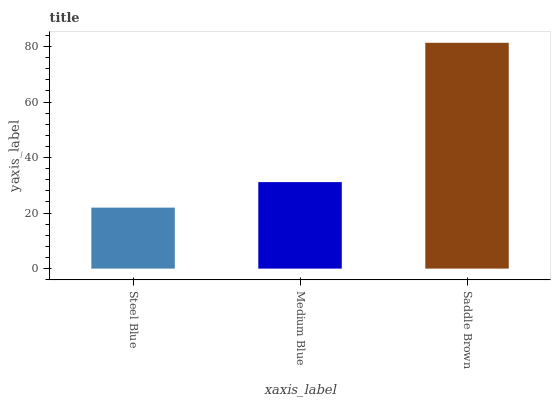Is Medium Blue the minimum?
Answer yes or no. No. Is Medium Blue the maximum?
Answer yes or no. No. Is Medium Blue greater than Steel Blue?
Answer yes or no. Yes. Is Steel Blue less than Medium Blue?
Answer yes or no. Yes. Is Steel Blue greater than Medium Blue?
Answer yes or no. No. Is Medium Blue less than Steel Blue?
Answer yes or no. No. Is Medium Blue the high median?
Answer yes or no. Yes. Is Medium Blue the low median?
Answer yes or no. Yes. Is Saddle Brown the high median?
Answer yes or no. No. Is Saddle Brown the low median?
Answer yes or no. No. 